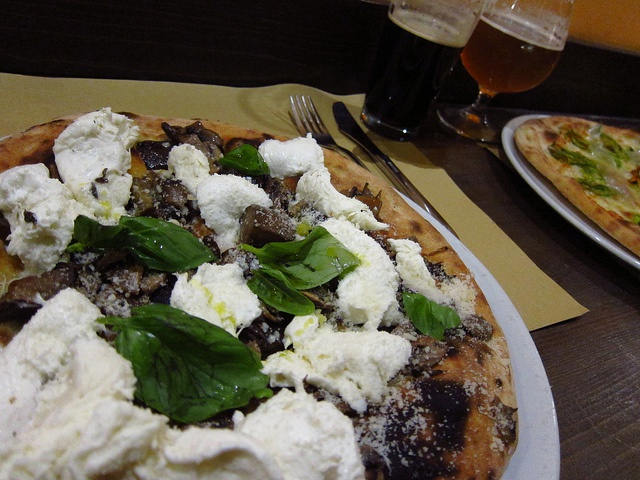Describe the objects in this image and their specific colors. I can see pizza in black, lightgray, darkgray, and gray tones, dining table in black and gray tones, cup in black and gray tones, pizza in black and olive tones, and wine glass in black, gray, and maroon tones in this image. 